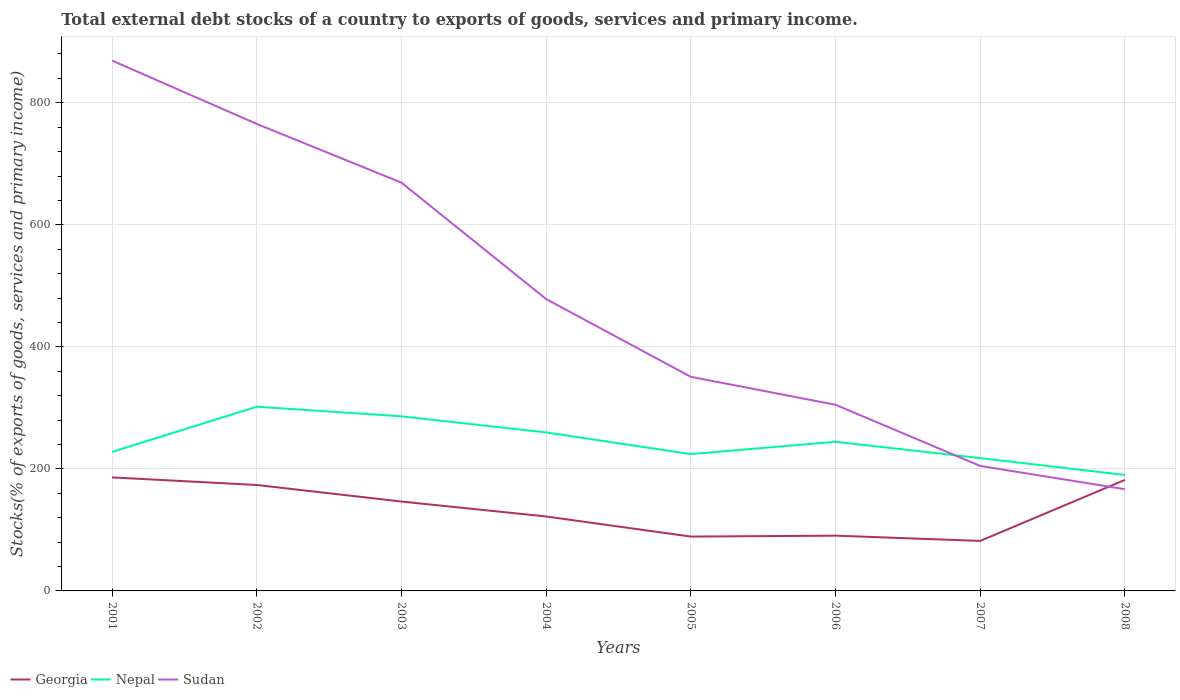How many different coloured lines are there?
Keep it short and to the point. 3. Is the number of lines equal to the number of legend labels?
Offer a terse response. Yes. Across all years, what is the maximum total debt stocks in Sudan?
Ensure brevity in your answer.  166.66. In which year was the total debt stocks in Nepal maximum?
Keep it short and to the point. 2008. What is the total total debt stocks in Sudan in the graph?
Give a very brief answer. 273.5. What is the difference between the highest and the second highest total debt stocks in Georgia?
Your answer should be very brief. 104.11. Is the total debt stocks in Sudan strictly greater than the total debt stocks in Georgia over the years?
Offer a very short reply. No. How many years are there in the graph?
Your response must be concise. 8. What is the difference between two consecutive major ticks on the Y-axis?
Ensure brevity in your answer.  200. Does the graph contain grids?
Your response must be concise. Yes. What is the title of the graph?
Make the answer very short. Total external debt stocks of a country to exports of goods, services and primary income. What is the label or title of the Y-axis?
Offer a very short reply. Stocks(% of exports of goods, services and primary income). What is the Stocks(% of exports of goods, services and primary income) of Georgia in 2001?
Your answer should be compact. 186.05. What is the Stocks(% of exports of goods, services and primary income) of Nepal in 2001?
Provide a succinct answer. 227.85. What is the Stocks(% of exports of goods, services and primary income) in Sudan in 2001?
Offer a very short reply. 869.18. What is the Stocks(% of exports of goods, services and primary income) in Georgia in 2002?
Provide a short and direct response. 173.63. What is the Stocks(% of exports of goods, services and primary income) of Nepal in 2002?
Ensure brevity in your answer.  301.91. What is the Stocks(% of exports of goods, services and primary income) in Sudan in 2002?
Your answer should be very brief. 765.42. What is the Stocks(% of exports of goods, services and primary income) of Georgia in 2003?
Your response must be concise. 146.49. What is the Stocks(% of exports of goods, services and primary income) of Nepal in 2003?
Provide a succinct answer. 286.16. What is the Stocks(% of exports of goods, services and primary income) in Sudan in 2003?
Offer a very short reply. 669.18. What is the Stocks(% of exports of goods, services and primary income) of Georgia in 2004?
Your response must be concise. 122.02. What is the Stocks(% of exports of goods, services and primary income) in Nepal in 2004?
Offer a very short reply. 259.79. What is the Stocks(% of exports of goods, services and primary income) in Sudan in 2004?
Offer a very short reply. 478.39. What is the Stocks(% of exports of goods, services and primary income) of Georgia in 2005?
Offer a terse response. 89.07. What is the Stocks(% of exports of goods, services and primary income) in Nepal in 2005?
Your answer should be very brief. 224.24. What is the Stocks(% of exports of goods, services and primary income) of Sudan in 2005?
Make the answer very short. 350.9. What is the Stocks(% of exports of goods, services and primary income) in Georgia in 2006?
Provide a succinct answer. 90.58. What is the Stocks(% of exports of goods, services and primary income) in Nepal in 2006?
Keep it short and to the point. 244.46. What is the Stocks(% of exports of goods, services and primary income) in Sudan in 2006?
Provide a succinct answer. 305.09. What is the Stocks(% of exports of goods, services and primary income) in Georgia in 2007?
Your response must be concise. 81.94. What is the Stocks(% of exports of goods, services and primary income) of Nepal in 2007?
Provide a succinct answer. 217.7. What is the Stocks(% of exports of goods, services and primary income) in Sudan in 2007?
Provide a short and direct response. 204.89. What is the Stocks(% of exports of goods, services and primary income) in Georgia in 2008?
Give a very brief answer. 181.93. What is the Stocks(% of exports of goods, services and primary income) of Nepal in 2008?
Your answer should be compact. 190.02. What is the Stocks(% of exports of goods, services and primary income) in Sudan in 2008?
Offer a very short reply. 166.66. Across all years, what is the maximum Stocks(% of exports of goods, services and primary income) in Georgia?
Your answer should be very brief. 186.05. Across all years, what is the maximum Stocks(% of exports of goods, services and primary income) in Nepal?
Your response must be concise. 301.91. Across all years, what is the maximum Stocks(% of exports of goods, services and primary income) in Sudan?
Make the answer very short. 869.18. Across all years, what is the minimum Stocks(% of exports of goods, services and primary income) of Georgia?
Give a very brief answer. 81.94. Across all years, what is the minimum Stocks(% of exports of goods, services and primary income) in Nepal?
Your answer should be compact. 190.02. Across all years, what is the minimum Stocks(% of exports of goods, services and primary income) in Sudan?
Your response must be concise. 166.66. What is the total Stocks(% of exports of goods, services and primary income) of Georgia in the graph?
Make the answer very short. 1071.71. What is the total Stocks(% of exports of goods, services and primary income) in Nepal in the graph?
Ensure brevity in your answer.  1952.13. What is the total Stocks(% of exports of goods, services and primary income) of Sudan in the graph?
Make the answer very short. 3809.7. What is the difference between the Stocks(% of exports of goods, services and primary income) of Georgia in 2001 and that in 2002?
Ensure brevity in your answer.  12.42. What is the difference between the Stocks(% of exports of goods, services and primary income) of Nepal in 2001 and that in 2002?
Your answer should be compact. -74.06. What is the difference between the Stocks(% of exports of goods, services and primary income) in Sudan in 2001 and that in 2002?
Ensure brevity in your answer.  103.76. What is the difference between the Stocks(% of exports of goods, services and primary income) of Georgia in 2001 and that in 2003?
Your response must be concise. 39.56. What is the difference between the Stocks(% of exports of goods, services and primary income) of Nepal in 2001 and that in 2003?
Make the answer very short. -58.32. What is the difference between the Stocks(% of exports of goods, services and primary income) of Sudan in 2001 and that in 2003?
Your answer should be compact. 200. What is the difference between the Stocks(% of exports of goods, services and primary income) of Georgia in 2001 and that in 2004?
Your answer should be compact. 64.03. What is the difference between the Stocks(% of exports of goods, services and primary income) in Nepal in 2001 and that in 2004?
Keep it short and to the point. -31.94. What is the difference between the Stocks(% of exports of goods, services and primary income) of Sudan in 2001 and that in 2004?
Your answer should be compact. 390.79. What is the difference between the Stocks(% of exports of goods, services and primary income) of Georgia in 2001 and that in 2005?
Ensure brevity in your answer.  96.98. What is the difference between the Stocks(% of exports of goods, services and primary income) of Nepal in 2001 and that in 2005?
Give a very brief answer. 3.61. What is the difference between the Stocks(% of exports of goods, services and primary income) of Sudan in 2001 and that in 2005?
Your response must be concise. 518.27. What is the difference between the Stocks(% of exports of goods, services and primary income) of Georgia in 2001 and that in 2006?
Provide a succinct answer. 95.47. What is the difference between the Stocks(% of exports of goods, services and primary income) in Nepal in 2001 and that in 2006?
Provide a succinct answer. -16.61. What is the difference between the Stocks(% of exports of goods, services and primary income) in Sudan in 2001 and that in 2006?
Offer a terse response. 564.09. What is the difference between the Stocks(% of exports of goods, services and primary income) of Georgia in 2001 and that in 2007?
Provide a succinct answer. 104.11. What is the difference between the Stocks(% of exports of goods, services and primary income) of Nepal in 2001 and that in 2007?
Offer a very short reply. 10.14. What is the difference between the Stocks(% of exports of goods, services and primary income) in Sudan in 2001 and that in 2007?
Your answer should be compact. 664.29. What is the difference between the Stocks(% of exports of goods, services and primary income) of Georgia in 2001 and that in 2008?
Offer a terse response. 4.12. What is the difference between the Stocks(% of exports of goods, services and primary income) of Nepal in 2001 and that in 2008?
Give a very brief answer. 37.82. What is the difference between the Stocks(% of exports of goods, services and primary income) of Sudan in 2001 and that in 2008?
Your answer should be compact. 702.52. What is the difference between the Stocks(% of exports of goods, services and primary income) in Georgia in 2002 and that in 2003?
Keep it short and to the point. 27.14. What is the difference between the Stocks(% of exports of goods, services and primary income) in Nepal in 2002 and that in 2003?
Offer a terse response. 15.74. What is the difference between the Stocks(% of exports of goods, services and primary income) in Sudan in 2002 and that in 2003?
Your answer should be compact. 96.25. What is the difference between the Stocks(% of exports of goods, services and primary income) of Georgia in 2002 and that in 2004?
Make the answer very short. 51.61. What is the difference between the Stocks(% of exports of goods, services and primary income) in Nepal in 2002 and that in 2004?
Your answer should be very brief. 42.12. What is the difference between the Stocks(% of exports of goods, services and primary income) in Sudan in 2002 and that in 2004?
Ensure brevity in your answer.  287.04. What is the difference between the Stocks(% of exports of goods, services and primary income) of Georgia in 2002 and that in 2005?
Ensure brevity in your answer.  84.56. What is the difference between the Stocks(% of exports of goods, services and primary income) of Nepal in 2002 and that in 2005?
Your answer should be compact. 77.67. What is the difference between the Stocks(% of exports of goods, services and primary income) in Sudan in 2002 and that in 2005?
Your response must be concise. 414.52. What is the difference between the Stocks(% of exports of goods, services and primary income) in Georgia in 2002 and that in 2006?
Make the answer very short. 83.05. What is the difference between the Stocks(% of exports of goods, services and primary income) of Nepal in 2002 and that in 2006?
Keep it short and to the point. 57.45. What is the difference between the Stocks(% of exports of goods, services and primary income) in Sudan in 2002 and that in 2006?
Ensure brevity in your answer.  460.33. What is the difference between the Stocks(% of exports of goods, services and primary income) of Georgia in 2002 and that in 2007?
Make the answer very short. 91.69. What is the difference between the Stocks(% of exports of goods, services and primary income) of Nepal in 2002 and that in 2007?
Your response must be concise. 84.21. What is the difference between the Stocks(% of exports of goods, services and primary income) of Sudan in 2002 and that in 2007?
Give a very brief answer. 560.53. What is the difference between the Stocks(% of exports of goods, services and primary income) of Georgia in 2002 and that in 2008?
Your response must be concise. -8.3. What is the difference between the Stocks(% of exports of goods, services and primary income) in Nepal in 2002 and that in 2008?
Make the answer very short. 111.88. What is the difference between the Stocks(% of exports of goods, services and primary income) of Sudan in 2002 and that in 2008?
Your answer should be compact. 598.77. What is the difference between the Stocks(% of exports of goods, services and primary income) of Georgia in 2003 and that in 2004?
Offer a terse response. 24.47. What is the difference between the Stocks(% of exports of goods, services and primary income) in Nepal in 2003 and that in 2004?
Give a very brief answer. 26.37. What is the difference between the Stocks(% of exports of goods, services and primary income) in Sudan in 2003 and that in 2004?
Offer a very short reply. 190.79. What is the difference between the Stocks(% of exports of goods, services and primary income) in Georgia in 2003 and that in 2005?
Ensure brevity in your answer.  57.42. What is the difference between the Stocks(% of exports of goods, services and primary income) of Nepal in 2003 and that in 2005?
Ensure brevity in your answer.  61.92. What is the difference between the Stocks(% of exports of goods, services and primary income) of Sudan in 2003 and that in 2005?
Your answer should be very brief. 318.27. What is the difference between the Stocks(% of exports of goods, services and primary income) of Georgia in 2003 and that in 2006?
Provide a short and direct response. 55.91. What is the difference between the Stocks(% of exports of goods, services and primary income) of Nepal in 2003 and that in 2006?
Your answer should be very brief. 41.7. What is the difference between the Stocks(% of exports of goods, services and primary income) in Sudan in 2003 and that in 2006?
Keep it short and to the point. 364.08. What is the difference between the Stocks(% of exports of goods, services and primary income) in Georgia in 2003 and that in 2007?
Ensure brevity in your answer.  64.55. What is the difference between the Stocks(% of exports of goods, services and primary income) in Nepal in 2003 and that in 2007?
Provide a short and direct response. 68.46. What is the difference between the Stocks(% of exports of goods, services and primary income) of Sudan in 2003 and that in 2007?
Keep it short and to the point. 464.29. What is the difference between the Stocks(% of exports of goods, services and primary income) in Georgia in 2003 and that in 2008?
Ensure brevity in your answer.  -35.44. What is the difference between the Stocks(% of exports of goods, services and primary income) of Nepal in 2003 and that in 2008?
Offer a very short reply. 96.14. What is the difference between the Stocks(% of exports of goods, services and primary income) of Sudan in 2003 and that in 2008?
Your answer should be very brief. 502.52. What is the difference between the Stocks(% of exports of goods, services and primary income) in Georgia in 2004 and that in 2005?
Provide a succinct answer. 32.94. What is the difference between the Stocks(% of exports of goods, services and primary income) of Nepal in 2004 and that in 2005?
Provide a short and direct response. 35.55. What is the difference between the Stocks(% of exports of goods, services and primary income) in Sudan in 2004 and that in 2005?
Offer a terse response. 127.48. What is the difference between the Stocks(% of exports of goods, services and primary income) of Georgia in 2004 and that in 2006?
Your response must be concise. 31.44. What is the difference between the Stocks(% of exports of goods, services and primary income) of Nepal in 2004 and that in 2006?
Give a very brief answer. 15.33. What is the difference between the Stocks(% of exports of goods, services and primary income) of Sudan in 2004 and that in 2006?
Offer a terse response. 173.3. What is the difference between the Stocks(% of exports of goods, services and primary income) of Georgia in 2004 and that in 2007?
Offer a very short reply. 40.07. What is the difference between the Stocks(% of exports of goods, services and primary income) of Nepal in 2004 and that in 2007?
Offer a very short reply. 42.09. What is the difference between the Stocks(% of exports of goods, services and primary income) in Sudan in 2004 and that in 2007?
Offer a terse response. 273.5. What is the difference between the Stocks(% of exports of goods, services and primary income) in Georgia in 2004 and that in 2008?
Ensure brevity in your answer.  -59.91. What is the difference between the Stocks(% of exports of goods, services and primary income) in Nepal in 2004 and that in 2008?
Offer a very short reply. 69.77. What is the difference between the Stocks(% of exports of goods, services and primary income) of Sudan in 2004 and that in 2008?
Keep it short and to the point. 311.73. What is the difference between the Stocks(% of exports of goods, services and primary income) in Georgia in 2005 and that in 2006?
Offer a very short reply. -1.5. What is the difference between the Stocks(% of exports of goods, services and primary income) of Nepal in 2005 and that in 2006?
Your answer should be compact. -20.22. What is the difference between the Stocks(% of exports of goods, services and primary income) of Sudan in 2005 and that in 2006?
Give a very brief answer. 45.81. What is the difference between the Stocks(% of exports of goods, services and primary income) of Georgia in 2005 and that in 2007?
Give a very brief answer. 7.13. What is the difference between the Stocks(% of exports of goods, services and primary income) of Nepal in 2005 and that in 2007?
Your answer should be compact. 6.54. What is the difference between the Stocks(% of exports of goods, services and primary income) of Sudan in 2005 and that in 2007?
Provide a short and direct response. 146.02. What is the difference between the Stocks(% of exports of goods, services and primary income) in Georgia in 2005 and that in 2008?
Provide a short and direct response. -92.85. What is the difference between the Stocks(% of exports of goods, services and primary income) of Nepal in 2005 and that in 2008?
Your answer should be compact. 34.21. What is the difference between the Stocks(% of exports of goods, services and primary income) of Sudan in 2005 and that in 2008?
Your response must be concise. 184.25. What is the difference between the Stocks(% of exports of goods, services and primary income) in Georgia in 2006 and that in 2007?
Your answer should be very brief. 8.63. What is the difference between the Stocks(% of exports of goods, services and primary income) of Nepal in 2006 and that in 2007?
Make the answer very short. 26.76. What is the difference between the Stocks(% of exports of goods, services and primary income) in Sudan in 2006 and that in 2007?
Your answer should be very brief. 100.2. What is the difference between the Stocks(% of exports of goods, services and primary income) in Georgia in 2006 and that in 2008?
Provide a short and direct response. -91.35. What is the difference between the Stocks(% of exports of goods, services and primary income) in Nepal in 2006 and that in 2008?
Your answer should be very brief. 54.43. What is the difference between the Stocks(% of exports of goods, services and primary income) in Sudan in 2006 and that in 2008?
Provide a short and direct response. 138.43. What is the difference between the Stocks(% of exports of goods, services and primary income) in Georgia in 2007 and that in 2008?
Your answer should be compact. -99.99. What is the difference between the Stocks(% of exports of goods, services and primary income) in Nepal in 2007 and that in 2008?
Offer a terse response. 27.68. What is the difference between the Stocks(% of exports of goods, services and primary income) of Sudan in 2007 and that in 2008?
Provide a short and direct response. 38.23. What is the difference between the Stocks(% of exports of goods, services and primary income) in Georgia in 2001 and the Stocks(% of exports of goods, services and primary income) in Nepal in 2002?
Offer a very short reply. -115.86. What is the difference between the Stocks(% of exports of goods, services and primary income) of Georgia in 2001 and the Stocks(% of exports of goods, services and primary income) of Sudan in 2002?
Offer a terse response. -579.37. What is the difference between the Stocks(% of exports of goods, services and primary income) of Nepal in 2001 and the Stocks(% of exports of goods, services and primary income) of Sudan in 2002?
Your answer should be very brief. -537.58. What is the difference between the Stocks(% of exports of goods, services and primary income) in Georgia in 2001 and the Stocks(% of exports of goods, services and primary income) in Nepal in 2003?
Offer a terse response. -100.11. What is the difference between the Stocks(% of exports of goods, services and primary income) in Georgia in 2001 and the Stocks(% of exports of goods, services and primary income) in Sudan in 2003?
Offer a very short reply. -483.13. What is the difference between the Stocks(% of exports of goods, services and primary income) of Nepal in 2001 and the Stocks(% of exports of goods, services and primary income) of Sudan in 2003?
Ensure brevity in your answer.  -441.33. What is the difference between the Stocks(% of exports of goods, services and primary income) in Georgia in 2001 and the Stocks(% of exports of goods, services and primary income) in Nepal in 2004?
Give a very brief answer. -73.74. What is the difference between the Stocks(% of exports of goods, services and primary income) of Georgia in 2001 and the Stocks(% of exports of goods, services and primary income) of Sudan in 2004?
Your response must be concise. -292.34. What is the difference between the Stocks(% of exports of goods, services and primary income) in Nepal in 2001 and the Stocks(% of exports of goods, services and primary income) in Sudan in 2004?
Make the answer very short. -250.54. What is the difference between the Stocks(% of exports of goods, services and primary income) in Georgia in 2001 and the Stocks(% of exports of goods, services and primary income) in Nepal in 2005?
Your answer should be very brief. -38.19. What is the difference between the Stocks(% of exports of goods, services and primary income) in Georgia in 2001 and the Stocks(% of exports of goods, services and primary income) in Sudan in 2005?
Your response must be concise. -164.85. What is the difference between the Stocks(% of exports of goods, services and primary income) in Nepal in 2001 and the Stocks(% of exports of goods, services and primary income) in Sudan in 2005?
Give a very brief answer. -123.06. What is the difference between the Stocks(% of exports of goods, services and primary income) of Georgia in 2001 and the Stocks(% of exports of goods, services and primary income) of Nepal in 2006?
Your response must be concise. -58.41. What is the difference between the Stocks(% of exports of goods, services and primary income) of Georgia in 2001 and the Stocks(% of exports of goods, services and primary income) of Sudan in 2006?
Your answer should be compact. -119.04. What is the difference between the Stocks(% of exports of goods, services and primary income) of Nepal in 2001 and the Stocks(% of exports of goods, services and primary income) of Sudan in 2006?
Your response must be concise. -77.25. What is the difference between the Stocks(% of exports of goods, services and primary income) in Georgia in 2001 and the Stocks(% of exports of goods, services and primary income) in Nepal in 2007?
Offer a very short reply. -31.65. What is the difference between the Stocks(% of exports of goods, services and primary income) in Georgia in 2001 and the Stocks(% of exports of goods, services and primary income) in Sudan in 2007?
Your response must be concise. -18.84. What is the difference between the Stocks(% of exports of goods, services and primary income) in Nepal in 2001 and the Stocks(% of exports of goods, services and primary income) in Sudan in 2007?
Your response must be concise. 22.96. What is the difference between the Stocks(% of exports of goods, services and primary income) in Georgia in 2001 and the Stocks(% of exports of goods, services and primary income) in Nepal in 2008?
Offer a terse response. -3.97. What is the difference between the Stocks(% of exports of goods, services and primary income) of Georgia in 2001 and the Stocks(% of exports of goods, services and primary income) of Sudan in 2008?
Ensure brevity in your answer.  19.39. What is the difference between the Stocks(% of exports of goods, services and primary income) in Nepal in 2001 and the Stocks(% of exports of goods, services and primary income) in Sudan in 2008?
Your answer should be very brief. 61.19. What is the difference between the Stocks(% of exports of goods, services and primary income) in Georgia in 2002 and the Stocks(% of exports of goods, services and primary income) in Nepal in 2003?
Offer a very short reply. -112.53. What is the difference between the Stocks(% of exports of goods, services and primary income) of Georgia in 2002 and the Stocks(% of exports of goods, services and primary income) of Sudan in 2003?
Make the answer very short. -495.54. What is the difference between the Stocks(% of exports of goods, services and primary income) of Nepal in 2002 and the Stocks(% of exports of goods, services and primary income) of Sudan in 2003?
Provide a short and direct response. -367.27. What is the difference between the Stocks(% of exports of goods, services and primary income) of Georgia in 2002 and the Stocks(% of exports of goods, services and primary income) of Nepal in 2004?
Your answer should be compact. -86.16. What is the difference between the Stocks(% of exports of goods, services and primary income) of Georgia in 2002 and the Stocks(% of exports of goods, services and primary income) of Sudan in 2004?
Offer a very short reply. -304.76. What is the difference between the Stocks(% of exports of goods, services and primary income) in Nepal in 2002 and the Stocks(% of exports of goods, services and primary income) in Sudan in 2004?
Your answer should be very brief. -176.48. What is the difference between the Stocks(% of exports of goods, services and primary income) of Georgia in 2002 and the Stocks(% of exports of goods, services and primary income) of Nepal in 2005?
Keep it short and to the point. -50.61. What is the difference between the Stocks(% of exports of goods, services and primary income) of Georgia in 2002 and the Stocks(% of exports of goods, services and primary income) of Sudan in 2005?
Offer a very short reply. -177.27. What is the difference between the Stocks(% of exports of goods, services and primary income) in Nepal in 2002 and the Stocks(% of exports of goods, services and primary income) in Sudan in 2005?
Your answer should be compact. -49. What is the difference between the Stocks(% of exports of goods, services and primary income) of Georgia in 2002 and the Stocks(% of exports of goods, services and primary income) of Nepal in 2006?
Your answer should be compact. -70.83. What is the difference between the Stocks(% of exports of goods, services and primary income) in Georgia in 2002 and the Stocks(% of exports of goods, services and primary income) in Sudan in 2006?
Ensure brevity in your answer.  -131.46. What is the difference between the Stocks(% of exports of goods, services and primary income) of Nepal in 2002 and the Stocks(% of exports of goods, services and primary income) of Sudan in 2006?
Provide a succinct answer. -3.18. What is the difference between the Stocks(% of exports of goods, services and primary income) in Georgia in 2002 and the Stocks(% of exports of goods, services and primary income) in Nepal in 2007?
Offer a very short reply. -44.07. What is the difference between the Stocks(% of exports of goods, services and primary income) in Georgia in 2002 and the Stocks(% of exports of goods, services and primary income) in Sudan in 2007?
Your answer should be very brief. -31.26. What is the difference between the Stocks(% of exports of goods, services and primary income) of Nepal in 2002 and the Stocks(% of exports of goods, services and primary income) of Sudan in 2007?
Make the answer very short. 97.02. What is the difference between the Stocks(% of exports of goods, services and primary income) of Georgia in 2002 and the Stocks(% of exports of goods, services and primary income) of Nepal in 2008?
Provide a succinct answer. -16.39. What is the difference between the Stocks(% of exports of goods, services and primary income) of Georgia in 2002 and the Stocks(% of exports of goods, services and primary income) of Sudan in 2008?
Provide a succinct answer. 6.97. What is the difference between the Stocks(% of exports of goods, services and primary income) in Nepal in 2002 and the Stocks(% of exports of goods, services and primary income) in Sudan in 2008?
Provide a succinct answer. 135.25. What is the difference between the Stocks(% of exports of goods, services and primary income) of Georgia in 2003 and the Stocks(% of exports of goods, services and primary income) of Nepal in 2004?
Provide a succinct answer. -113.3. What is the difference between the Stocks(% of exports of goods, services and primary income) of Georgia in 2003 and the Stocks(% of exports of goods, services and primary income) of Sudan in 2004?
Ensure brevity in your answer.  -331.9. What is the difference between the Stocks(% of exports of goods, services and primary income) of Nepal in 2003 and the Stocks(% of exports of goods, services and primary income) of Sudan in 2004?
Offer a terse response. -192.22. What is the difference between the Stocks(% of exports of goods, services and primary income) in Georgia in 2003 and the Stocks(% of exports of goods, services and primary income) in Nepal in 2005?
Your answer should be compact. -77.75. What is the difference between the Stocks(% of exports of goods, services and primary income) of Georgia in 2003 and the Stocks(% of exports of goods, services and primary income) of Sudan in 2005?
Make the answer very short. -204.41. What is the difference between the Stocks(% of exports of goods, services and primary income) of Nepal in 2003 and the Stocks(% of exports of goods, services and primary income) of Sudan in 2005?
Keep it short and to the point. -64.74. What is the difference between the Stocks(% of exports of goods, services and primary income) of Georgia in 2003 and the Stocks(% of exports of goods, services and primary income) of Nepal in 2006?
Provide a succinct answer. -97.97. What is the difference between the Stocks(% of exports of goods, services and primary income) in Georgia in 2003 and the Stocks(% of exports of goods, services and primary income) in Sudan in 2006?
Make the answer very short. -158.6. What is the difference between the Stocks(% of exports of goods, services and primary income) in Nepal in 2003 and the Stocks(% of exports of goods, services and primary income) in Sudan in 2006?
Provide a succinct answer. -18.93. What is the difference between the Stocks(% of exports of goods, services and primary income) in Georgia in 2003 and the Stocks(% of exports of goods, services and primary income) in Nepal in 2007?
Keep it short and to the point. -71.21. What is the difference between the Stocks(% of exports of goods, services and primary income) of Georgia in 2003 and the Stocks(% of exports of goods, services and primary income) of Sudan in 2007?
Offer a terse response. -58.4. What is the difference between the Stocks(% of exports of goods, services and primary income) of Nepal in 2003 and the Stocks(% of exports of goods, services and primary income) of Sudan in 2007?
Make the answer very short. 81.28. What is the difference between the Stocks(% of exports of goods, services and primary income) in Georgia in 2003 and the Stocks(% of exports of goods, services and primary income) in Nepal in 2008?
Provide a succinct answer. -43.53. What is the difference between the Stocks(% of exports of goods, services and primary income) of Georgia in 2003 and the Stocks(% of exports of goods, services and primary income) of Sudan in 2008?
Provide a succinct answer. -20.17. What is the difference between the Stocks(% of exports of goods, services and primary income) of Nepal in 2003 and the Stocks(% of exports of goods, services and primary income) of Sudan in 2008?
Your answer should be very brief. 119.51. What is the difference between the Stocks(% of exports of goods, services and primary income) in Georgia in 2004 and the Stocks(% of exports of goods, services and primary income) in Nepal in 2005?
Give a very brief answer. -102.22. What is the difference between the Stocks(% of exports of goods, services and primary income) of Georgia in 2004 and the Stocks(% of exports of goods, services and primary income) of Sudan in 2005?
Provide a short and direct response. -228.89. What is the difference between the Stocks(% of exports of goods, services and primary income) in Nepal in 2004 and the Stocks(% of exports of goods, services and primary income) in Sudan in 2005?
Provide a short and direct response. -91.11. What is the difference between the Stocks(% of exports of goods, services and primary income) in Georgia in 2004 and the Stocks(% of exports of goods, services and primary income) in Nepal in 2006?
Your answer should be very brief. -122.44. What is the difference between the Stocks(% of exports of goods, services and primary income) in Georgia in 2004 and the Stocks(% of exports of goods, services and primary income) in Sudan in 2006?
Offer a very short reply. -183.08. What is the difference between the Stocks(% of exports of goods, services and primary income) of Nepal in 2004 and the Stocks(% of exports of goods, services and primary income) of Sudan in 2006?
Offer a very short reply. -45.3. What is the difference between the Stocks(% of exports of goods, services and primary income) in Georgia in 2004 and the Stocks(% of exports of goods, services and primary income) in Nepal in 2007?
Ensure brevity in your answer.  -95.69. What is the difference between the Stocks(% of exports of goods, services and primary income) of Georgia in 2004 and the Stocks(% of exports of goods, services and primary income) of Sudan in 2007?
Keep it short and to the point. -82.87. What is the difference between the Stocks(% of exports of goods, services and primary income) of Nepal in 2004 and the Stocks(% of exports of goods, services and primary income) of Sudan in 2007?
Offer a very short reply. 54.9. What is the difference between the Stocks(% of exports of goods, services and primary income) in Georgia in 2004 and the Stocks(% of exports of goods, services and primary income) in Nepal in 2008?
Keep it short and to the point. -68.01. What is the difference between the Stocks(% of exports of goods, services and primary income) of Georgia in 2004 and the Stocks(% of exports of goods, services and primary income) of Sudan in 2008?
Ensure brevity in your answer.  -44.64. What is the difference between the Stocks(% of exports of goods, services and primary income) of Nepal in 2004 and the Stocks(% of exports of goods, services and primary income) of Sudan in 2008?
Provide a short and direct response. 93.13. What is the difference between the Stocks(% of exports of goods, services and primary income) in Georgia in 2005 and the Stocks(% of exports of goods, services and primary income) in Nepal in 2006?
Your answer should be compact. -155.38. What is the difference between the Stocks(% of exports of goods, services and primary income) of Georgia in 2005 and the Stocks(% of exports of goods, services and primary income) of Sudan in 2006?
Offer a very short reply. -216.02. What is the difference between the Stocks(% of exports of goods, services and primary income) of Nepal in 2005 and the Stocks(% of exports of goods, services and primary income) of Sudan in 2006?
Your response must be concise. -80.85. What is the difference between the Stocks(% of exports of goods, services and primary income) of Georgia in 2005 and the Stocks(% of exports of goods, services and primary income) of Nepal in 2007?
Provide a succinct answer. -128.63. What is the difference between the Stocks(% of exports of goods, services and primary income) in Georgia in 2005 and the Stocks(% of exports of goods, services and primary income) in Sudan in 2007?
Your response must be concise. -115.81. What is the difference between the Stocks(% of exports of goods, services and primary income) of Nepal in 2005 and the Stocks(% of exports of goods, services and primary income) of Sudan in 2007?
Your answer should be compact. 19.35. What is the difference between the Stocks(% of exports of goods, services and primary income) in Georgia in 2005 and the Stocks(% of exports of goods, services and primary income) in Nepal in 2008?
Provide a short and direct response. -100.95. What is the difference between the Stocks(% of exports of goods, services and primary income) in Georgia in 2005 and the Stocks(% of exports of goods, services and primary income) in Sudan in 2008?
Make the answer very short. -77.58. What is the difference between the Stocks(% of exports of goods, services and primary income) of Nepal in 2005 and the Stocks(% of exports of goods, services and primary income) of Sudan in 2008?
Offer a very short reply. 57.58. What is the difference between the Stocks(% of exports of goods, services and primary income) in Georgia in 2006 and the Stocks(% of exports of goods, services and primary income) in Nepal in 2007?
Ensure brevity in your answer.  -127.13. What is the difference between the Stocks(% of exports of goods, services and primary income) of Georgia in 2006 and the Stocks(% of exports of goods, services and primary income) of Sudan in 2007?
Offer a very short reply. -114.31. What is the difference between the Stocks(% of exports of goods, services and primary income) of Nepal in 2006 and the Stocks(% of exports of goods, services and primary income) of Sudan in 2007?
Give a very brief answer. 39.57. What is the difference between the Stocks(% of exports of goods, services and primary income) in Georgia in 2006 and the Stocks(% of exports of goods, services and primary income) in Nepal in 2008?
Ensure brevity in your answer.  -99.45. What is the difference between the Stocks(% of exports of goods, services and primary income) of Georgia in 2006 and the Stocks(% of exports of goods, services and primary income) of Sudan in 2008?
Your response must be concise. -76.08. What is the difference between the Stocks(% of exports of goods, services and primary income) of Nepal in 2006 and the Stocks(% of exports of goods, services and primary income) of Sudan in 2008?
Make the answer very short. 77.8. What is the difference between the Stocks(% of exports of goods, services and primary income) of Georgia in 2007 and the Stocks(% of exports of goods, services and primary income) of Nepal in 2008?
Provide a short and direct response. -108.08. What is the difference between the Stocks(% of exports of goods, services and primary income) in Georgia in 2007 and the Stocks(% of exports of goods, services and primary income) in Sudan in 2008?
Provide a succinct answer. -84.71. What is the difference between the Stocks(% of exports of goods, services and primary income) of Nepal in 2007 and the Stocks(% of exports of goods, services and primary income) of Sudan in 2008?
Give a very brief answer. 51.05. What is the average Stocks(% of exports of goods, services and primary income) of Georgia per year?
Offer a very short reply. 133.96. What is the average Stocks(% of exports of goods, services and primary income) in Nepal per year?
Keep it short and to the point. 244.02. What is the average Stocks(% of exports of goods, services and primary income) of Sudan per year?
Offer a terse response. 476.21. In the year 2001, what is the difference between the Stocks(% of exports of goods, services and primary income) of Georgia and Stocks(% of exports of goods, services and primary income) of Nepal?
Your response must be concise. -41.8. In the year 2001, what is the difference between the Stocks(% of exports of goods, services and primary income) in Georgia and Stocks(% of exports of goods, services and primary income) in Sudan?
Ensure brevity in your answer.  -683.13. In the year 2001, what is the difference between the Stocks(% of exports of goods, services and primary income) in Nepal and Stocks(% of exports of goods, services and primary income) in Sudan?
Keep it short and to the point. -641.33. In the year 2002, what is the difference between the Stocks(% of exports of goods, services and primary income) in Georgia and Stocks(% of exports of goods, services and primary income) in Nepal?
Give a very brief answer. -128.28. In the year 2002, what is the difference between the Stocks(% of exports of goods, services and primary income) of Georgia and Stocks(% of exports of goods, services and primary income) of Sudan?
Offer a terse response. -591.79. In the year 2002, what is the difference between the Stocks(% of exports of goods, services and primary income) of Nepal and Stocks(% of exports of goods, services and primary income) of Sudan?
Make the answer very short. -463.51. In the year 2003, what is the difference between the Stocks(% of exports of goods, services and primary income) of Georgia and Stocks(% of exports of goods, services and primary income) of Nepal?
Your response must be concise. -139.67. In the year 2003, what is the difference between the Stocks(% of exports of goods, services and primary income) of Georgia and Stocks(% of exports of goods, services and primary income) of Sudan?
Provide a short and direct response. -522.69. In the year 2003, what is the difference between the Stocks(% of exports of goods, services and primary income) of Nepal and Stocks(% of exports of goods, services and primary income) of Sudan?
Provide a succinct answer. -383.01. In the year 2004, what is the difference between the Stocks(% of exports of goods, services and primary income) in Georgia and Stocks(% of exports of goods, services and primary income) in Nepal?
Make the answer very short. -137.77. In the year 2004, what is the difference between the Stocks(% of exports of goods, services and primary income) of Georgia and Stocks(% of exports of goods, services and primary income) of Sudan?
Provide a succinct answer. -356.37. In the year 2004, what is the difference between the Stocks(% of exports of goods, services and primary income) of Nepal and Stocks(% of exports of goods, services and primary income) of Sudan?
Offer a terse response. -218.6. In the year 2005, what is the difference between the Stocks(% of exports of goods, services and primary income) in Georgia and Stocks(% of exports of goods, services and primary income) in Nepal?
Your answer should be very brief. -135.16. In the year 2005, what is the difference between the Stocks(% of exports of goods, services and primary income) of Georgia and Stocks(% of exports of goods, services and primary income) of Sudan?
Offer a terse response. -261.83. In the year 2005, what is the difference between the Stocks(% of exports of goods, services and primary income) in Nepal and Stocks(% of exports of goods, services and primary income) in Sudan?
Your answer should be very brief. -126.67. In the year 2006, what is the difference between the Stocks(% of exports of goods, services and primary income) of Georgia and Stocks(% of exports of goods, services and primary income) of Nepal?
Make the answer very short. -153.88. In the year 2006, what is the difference between the Stocks(% of exports of goods, services and primary income) in Georgia and Stocks(% of exports of goods, services and primary income) in Sudan?
Your answer should be very brief. -214.51. In the year 2006, what is the difference between the Stocks(% of exports of goods, services and primary income) in Nepal and Stocks(% of exports of goods, services and primary income) in Sudan?
Keep it short and to the point. -60.63. In the year 2007, what is the difference between the Stocks(% of exports of goods, services and primary income) in Georgia and Stocks(% of exports of goods, services and primary income) in Nepal?
Your answer should be very brief. -135.76. In the year 2007, what is the difference between the Stocks(% of exports of goods, services and primary income) in Georgia and Stocks(% of exports of goods, services and primary income) in Sudan?
Offer a terse response. -122.94. In the year 2007, what is the difference between the Stocks(% of exports of goods, services and primary income) of Nepal and Stocks(% of exports of goods, services and primary income) of Sudan?
Keep it short and to the point. 12.81. In the year 2008, what is the difference between the Stocks(% of exports of goods, services and primary income) in Georgia and Stocks(% of exports of goods, services and primary income) in Nepal?
Offer a terse response. -8.1. In the year 2008, what is the difference between the Stocks(% of exports of goods, services and primary income) in Georgia and Stocks(% of exports of goods, services and primary income) in Sudan?
Give a very brief answer. 15.27. In the year 2008, what is the difference between the Stocks(% of exports of goods, services and primary income) in Nepal and Stocks(% of exports of goods, services and primary income) in Sudan?
Give a very brief answer. 23.37. What is the ratio of the Stocks(% of exports of goods, services and primary income) of Georgia in 2001 to that in 2002?
Give a very brief answer. 1.07. What is the ratio of the Stocks(% of exports of goods, services and primary income) in Nepal in 2001 to that in 2002?
Offer a terse response. 0.75. What is the ratio of the Stocks(% of exports of goods, services and primary income) of Sudan in 2001 to that in 2002?
Your answer should be very brief. 1.14. What is the ratio of the Stocks(% of exports of goods, services and primary income) in Georgia in 2001 to that in 2003?
Provide a succinct answer. 1.27. What is the ratio of the Stocks(% of exports of goods, services and primary income) in Nepal in 2001 to that in 2003?
Give a very brief answer. 0.8. What is the ratio of the Stocks(% of exports of goods, services and primary income) in Sudan in 2001 to that in 2003?
Your response must be concise. 1.3. What is the ratio of the Stocks(% of exports of goods, services and primary income) in Georgia in 2001 to that in 2004?
Your response must be concise. 1.52. What is the ratio of the Stocks(% of exports of goods, services and primary income) in Nepal in 2001 to that in 2004?
Keep it short and to the point. 0.88. What is the ratio of the Stocks(% of exports of goods, services and primary income) of Sudan in 2001 to that in 2004?
Your response must be concise. 1.82. What is the ratio of the Stocks(% of exports of goods, services and primary income) of Georgia in 2001 to that in 2005?
Your answer should be compact. 2.09. What is the ratio of the Stocks(% of exports of goods, services and primary income) in Nepal in 2001 to that in 2005?
Offer a very short reply. 1.02. What is the ratio of the Stocks(% of exports of goods, services and primary income) of Sudan in 2001 to that in 2005?
Provide a succinct answer. 2.48. What is the ratio of the Stocks(% of exports of goods, services and primary income) of Georgia in 2001 to that in 2006?
Your response must be concise. 2.05. What is the ratio of the Stocks(% of exports of goods, services and primary income) of Nepal in 2001 to that in 2006?
Offer a very short reply. 0.93. What is the ratio of the Stocks(% of exports of goods, services and primary income) of Sudan in 2001 to that in 2006?
Provide a short and direct response. 2.85. What is the ratio of the Stocks(% of exports of goods, services and primary income) in Georgia in 2001 to that in 2007?
Provide a short and direct response. 2.27. What is the ratio of the Stocks(% of exports of goods, services and primary income) of Nepal in 2001 to that in 2007?
Your answer should be compact. 1.05. What is the ratio of the Stocks(% of exports of goods, services and primary income) of Sudan in 2001 to that in 2007?
Ensure brevity in your answer.  4.24. What is the ratio of the Stocks(% of exports of goods, services and primary income) in Georgia in 2001 to that in 2008?
Keep it short and to the point. 1.02. What is the ratio of the Stocks(% of exports of goods, services and primary income) of Nepal in 2001 to that in 2008?
Give a very brief answer. 1.2. What is the ratio of the Stocks(% of exports of goods, services and primary income) in Sudan in 2001 to that in 2008?
Keep it short and to the point. 5.22. What is the ratio of the Stocks(% of exports of goods, services and primary income) of Georgia in 2002 to that in 2003?
Give a very brief answer. 1.19. What is the ratio of the Stocks(% of exports of goods, services and primary income) of Nepal in 2002 to that in 2003?
Provide a succinct answer. 1.05. What is the ratio of the Stocks(% of exports of goods, services and primary income) of Sudan in 2002 to that in 2003?
Ensure brevity in your answer.  1.14. What is the ratio of the Stocks(% of exports of goods, services and primary income) in Georgia in 2002 to that in 2004?
Make the answer very short. 1.42. What is the ratio of the Stocks(% of exports of goods, services and primary income) in Nepal in 2002 to that in 2004?
Your response must be concise. 1.16. What is the ratio of the Stocks(% of exports of goods, services and primary income) in Georgia in 2002 to that in 2005?
Offer a very short reply. 1.95. What is the ratio of the Stocks(% of exports of goods, services and primary income) of Nepal in 2002 to that in 2005?
Provide a succinct answer. 1.35. What is the ratio of the Stocks(% of exports of goods, services and primary income) in Sudan in 2002 to that in 2005?
Offer a very short reply. 2.18. What is the ratio of the Stocks(% of exports of goods, services and primary income) of Georgia in 2002 to that in 2006?
Offer a terse response. 1.92. What is the ratio of the Stocks(% of exports of goods, services and primary income) of Nepal in 2002 to that in 2006?
Your answer should be compact. 1.24. What is the ratio of the Stocks(% of exports of goods, services and primary income) of Sudan in 2002 to that in 2006?
Keep it short and to the point. 2.51. What is the ratio of the Stocks(% of exports of goods, services and primary income) of Georgia in 2002 to that in 2007?
Keep it short and to the point. 2.12. What is the ratio of the Stocks(% of exports of goods, services and primary income) in Nepal in 2002 to that in 2007?
Make the answer very short. 1.39. What is the ratio of the Stocks(% of exports of goods, services and primary income) of Sudan in 2002 to that in 2007?
Give a very brief answer. 3.74. What is the ratio of the Stocks(% of exports of goods, services and primary income) in Georgia in 2002 to that in 2008?
Provide a succinct answer. 0.95. What is the ratio of the Stocks(% of exports of goods, services and primary income) in Nepal in 2002 to that in 2008?
Ensure brevity in your answer.  1.59. What is the ratio of the Stocks(% of exports of goods, services and primary income) in Sudan in 2002 to that in 2008?
Your answer should be compact. 4.59. What is the ratio of the Stocks(% of exports of goods, services and primary income) in Georgia in 2003 to that in 2004?
Keep it short and to the point. 1.2. What is the ratio of the Stocks(% of exports of goods, services and primary income) in Nepal in 2003 to that in 2004?
Provide a succinct answer. 1.1. What is the ratio of the Stocks(% of exports of goods, services and primary income) in Sudan in 2003 to that in 2004?
Keep it short and to the point. 1.4. What is the ratio of the Stocks(% of exports of goods, services and primary income) of Georgia in 2003 to that in 2005?
Your answer should be compact. 1.64. What is the ratio of the Stocks(% of exports of goods, services and primary income) in Nepal in 2003 to that in 2005?
Give a very brief answer. 1.28. What is the ratio of the Stocks(% of exports of goods, services and primary income) in Sudan in 2003 to that in 2005?
Make the answer very short. 1.91. What is the ratio of the Stocks(% of exports of goods, services and primary income) in Georgia in 2003 to that in 2006?
Your answer should be compact. 1.62. What is the ratio of the Stocks(% of exports of goods, services and primary income) of Nepal in 2003 to that in 2006?
Your answer should be compact. 1.17. What is the ratio of the Stocks(% of exports of goods, services and primary income) of Sudan in 2003 to that in 2006?
Provide a succinct answer. 2.19. What is the ratio of the Stocks(% of exports of goods, services and primary income) of Georgia in 2003 to that in 2007?
Your answer should be compact. 1.79. What is the ratio of the Stocks(% of exports of goods, services and primary income) of Nepal in 2003 to that in 2007?
Offer a very short reply. 1.31. What is the ratio of the Stocks(% of exports of goods, services and primary income) in Sudan in 2003 to that in 2007?
Your response must be concise. 3.27. What is the ratio of the Stocks(% of exports of goods, services and primary income) in Georgia in 2003 to that in 2008?
Keep it short and to the point. 0.81. What is the ratio of the Stocks(% of exports of goods, services and primary income) of Nepal in 2003 to that in 2008?
Provide a succinct answer. 1.51. What is the ratio of the Stocks(% of exports of goods, services and primary income) in Sudan in 2003 to that in 2008?
Provide a succinct answer. 4.02. What is the ratio of the Stocks(% of exports of goods, services and primary income) of Georgia in 2004 to that in 2005?
Give a very brief answer. 1.37. What is the ratio of the Stocks(% of exports of goods, services and primary income) of Nepal in 2004 to that in 2005?
Give a very brief answer. 1.16. What is the ratio of the Stocks(% of exports of goods, services and primary income) in Sudan in 2004 to that in 2005?
Your response must be concise. 1.36. What is the ratio of the Stocks(% of exports of goods, services and primary income) of Georgia in 2004 to that in 2006?
Provide a succinct answer. 1.35. What is the ratio of the Stocks(% of exports of goods, services and primary income) in Nepal in 2004 to that in 2006?
Offer a very short reply. 1.06. What is the ratio of the Stocks(% of exports of goods, services and primary income) in Sudan in 2004 to that in 2006?
Your response must be concise. 1.57. What is the ratio of the Stocks(% of exports of goods, services and primary income) in Georgia in 2004 to that in 2007?
Provide a succinct answer. 1.49. What is the ratio of the Stocks(% of exports of goods, services and primary income) in Nepal in 2004 to that in 2007?
Give a very brief answer. 1.19. What is the ratio of the Stocks(% of exports of goods, services and primary income) of Sudan in 2004 to that in 2007?
Your answer should be very brief. 2.33. What is the ratio of the Stocks(% of exports of goods, services and primary income) of Georgia in 2004 to that in 2008?
Your answer should be very brief. 0.67. What is the ratio of the Stocks(% of exports of goods, services and primary income) in Nepal in 2004 to that in 2008?
Offer a very short reply. 1.37. What is the ratio of the Stocks(% of exports of goods, services and primary income) in Sudan in 2004 to that in 2008?
Provide a short and direct response. 2.87. What is the ratio of the Stocks(% of exports of goods, services and primary income) in Georgia in 2005 to that in 2006?
Your answer should be very brief. 0.98. What is the ratio of the Stocks(% of exports of goods, services and primary income) of Nepal in 2005 to that in 2006?
Your answer should be very brief. 0.92. What is the ratio of the Stocks(% of exports of goods, services and primary income) of Sudan in 2005 to that in 2006?
Ensure brevity in your answer.  1.15. What is the ratio of the Stocks(% of exports of goods, services and primary income) in Georgia in 2005 to that in 2007?
Make the answer very short. 1.09. What is the ratio of the Stocks(% of exports of goods, services and primary income) of Nepal in 2005 to that in 2007?
Your answer should be very brief. 1.03. What is the ratio of the Stocks(% of exports of goods, services and primary income) of Sudan in 2005 to that in 2007?
Your answer should be compact. 1.71. What is the ratio of the Stocks(% of exports of goods, services and primary income) of Georgia in 2005 to that in 2008?
Offer a terse response. 0.49. What is the ratio of the Stocks(% of exports of goods, services and primary income) of Nepal in 2005 to that in 2008?
Give a very brief answer. 1.18. What is the ratio of the Stocks(% of exports of goods, services and primary income) in Sudan in 2005 to that in 2008?
Provide a short and direct response. 2.11. What is the ratio of the Stocks(% of exports of goods, services and primary income) in Georgia in 2006 to that in 2007?
Ensure brevity in your answer.  1.11. What is the ratio of the Stocks(% of exports of goods, services and primary income) in Nepal in 2006 to that in 2007?
Keep it short and to the point. 1.12. What is the ratio of the Stocks(% of exports of goods, services and primary income) of Sudan in 2006 to that in 2007?
Make the answer very short. 1.49. What is the ratio of the Stocks(% of exports of goods, services and primary income) in Georgia in 2006 to that in 2008?
Make the answer very short. 0.5. What is the ratio of the Stocks(% of exports of goods, services and primary income) in Nepal in 2006 to that in 2008?
Ensure brevity in your answer.  1.29. What is the ratio of the Stocks(% of exports of goods, services and primary income) of Sudan in 2006 to that in 2008?
Your response must be concise. 1.83. What is the ratio of the Stocks(% of exports of goods, services and primary income) of Georgia in 2007 to that in 2008?
Provide a short and direct response. 0.45. What is the ratio of the Stocks(% of exports of goods, services and primary income) of Nepal in 2007 to that in 2008?
Ensure brevity in your answer.  1.15. What is the ratio of the Stocks(% of exports of goods, services and primary income) of Sudan in 2007 to that in 2008?
Give a very brief answer. 1.23. What is the difference between the highest and the second highest Stocks(% of exports of goods, services and primary income) of Georgia?
Your response must be concise. 4.12. What is the difference between the highest and the second highest Stocks(% of exports of goods, services and primary income) of Nepal?
Your response must be concise. 15.74. What is the difference between the highest and the second highest Stocks(% of exports of goods, services and primary income) of Sudan?
Keep it short and to the point. 103.76. What is the difference between the highest and the lowest Stocks(% of exports of goods, services and primary income) of Georgia?
Give a very brief answer. 104.11. What is the difference between the highest and the lowest Stocks(% of exports of goods, services and primary income) in Nepal?
Make the answer very short. 111.88. What is the difference between the highest and the lowest Stocks(% of exports of goods, services and primary income) of Sudan?
Make the answer very short. 702.52. 